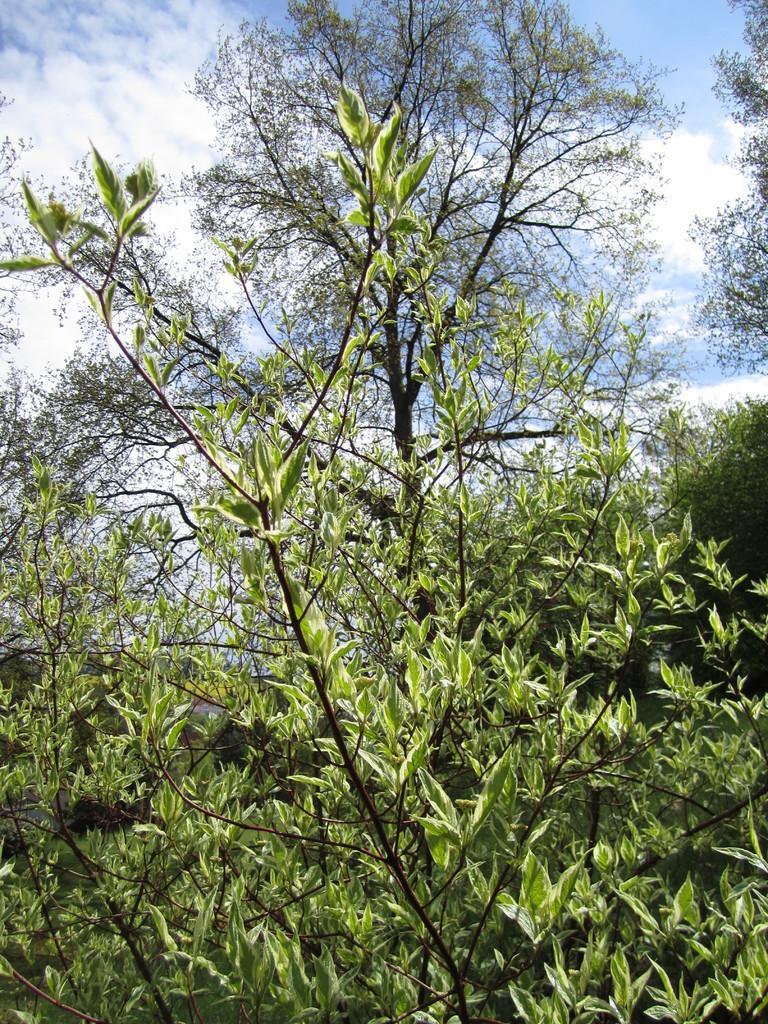Please provide a concise description of this image. In this image we can see branches and leaves. In the background there is sky with clouds. 